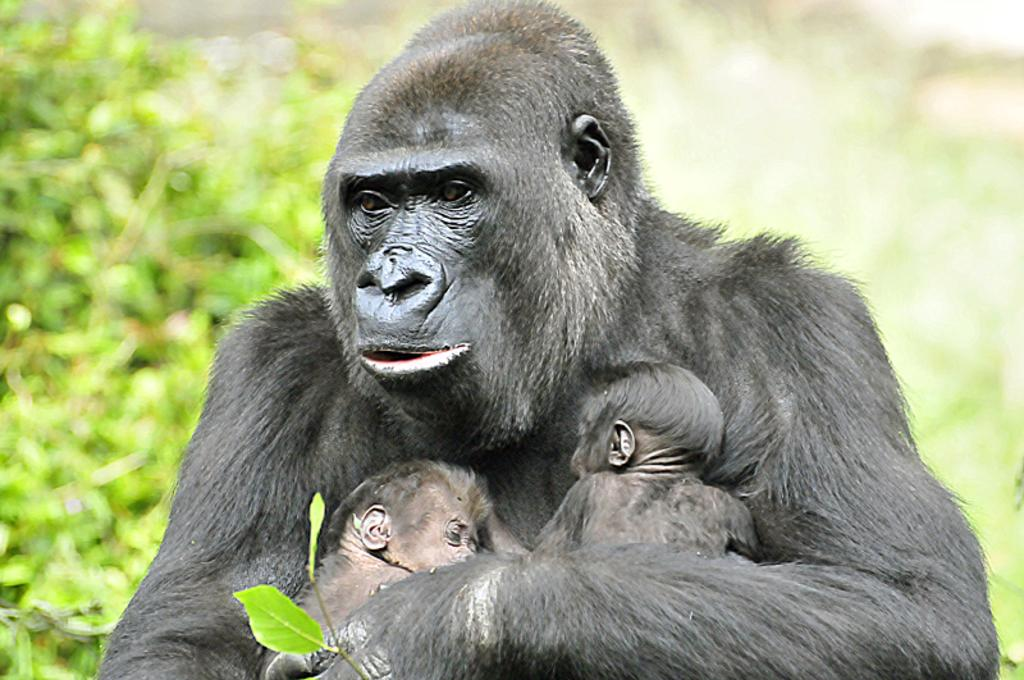What animal is the main subject of the picture? There is a chimpanzee in the picture. What is the chimpanzee doing in the picture? The chimpanzee is holding its babies with its hands. What can be seen in the background of the picture? There are trees in the background of the picture, and the background is blurred. Where might this picture have been taken? The picture might have been taken in a zoo. What type of brush can be seen in the chimpanzee's hand in the image? There is no brush present in the image; the chimpanzee is holding its babies with its hands. What kind of party is the chimpanzee attending in the image? There is no party depicted in the image; it shows a chimpanzee holding its babies in a natural setting. 